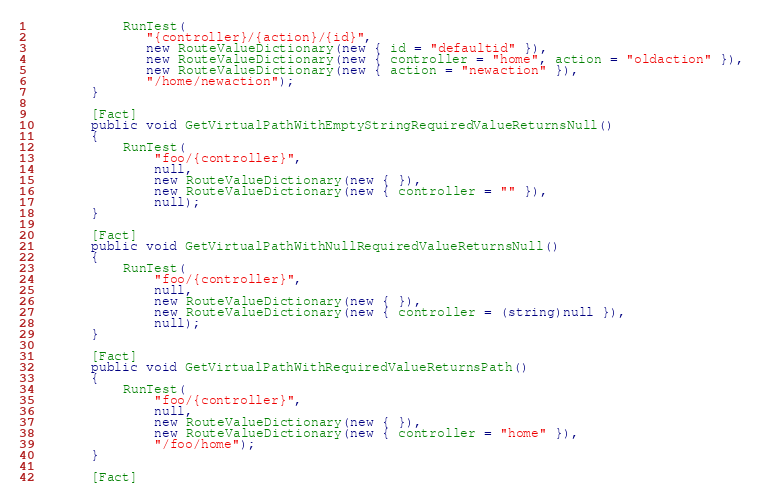<code> <loc_0><loc_0><loc_500><loc_500><_C#_>            RunTest(
               "{controller}/{action}/{id}",
               new RouteValueDictionary(new { id = "defaultid" }),
               new RouteValueDictionary(new { controller = "home", action = "oldaction" }),
               new RouteValueDictionary(new { action = "newaction" }),
               "/home/newaction");
        }

        [Fact]
        public void GetVirtualPathWithEmptyStringRequiredValueReturnsNull()
        {
            RunTest(
                "foo/{controller}",
                null,
                new RouteValueDictionary(new { }),
                new RouteValueDictionary(new { controller = "" }),
                null);
        }

        [Fact]
        public void GetVirtualPathWithNullRequiredValueReturnsNull()
        {
            RunTest(
                "foo/{controller}",
                null,
                new RouteValueDictionary(new { }),
                new RouteValueDictionary(new { controller = (string)null }),
                null);
        }

        [Fact]
        public void GetVirtualPathWithRequiredValueReturnsPath()
        {
            RunTest(
                "foo/{controller}",
                null,
                new RouteValueDictionary(new { }),
                new RouteValueDictionary(new { controller = "home" }),
                "/foo/home");
        }

        [Fact]</code> 